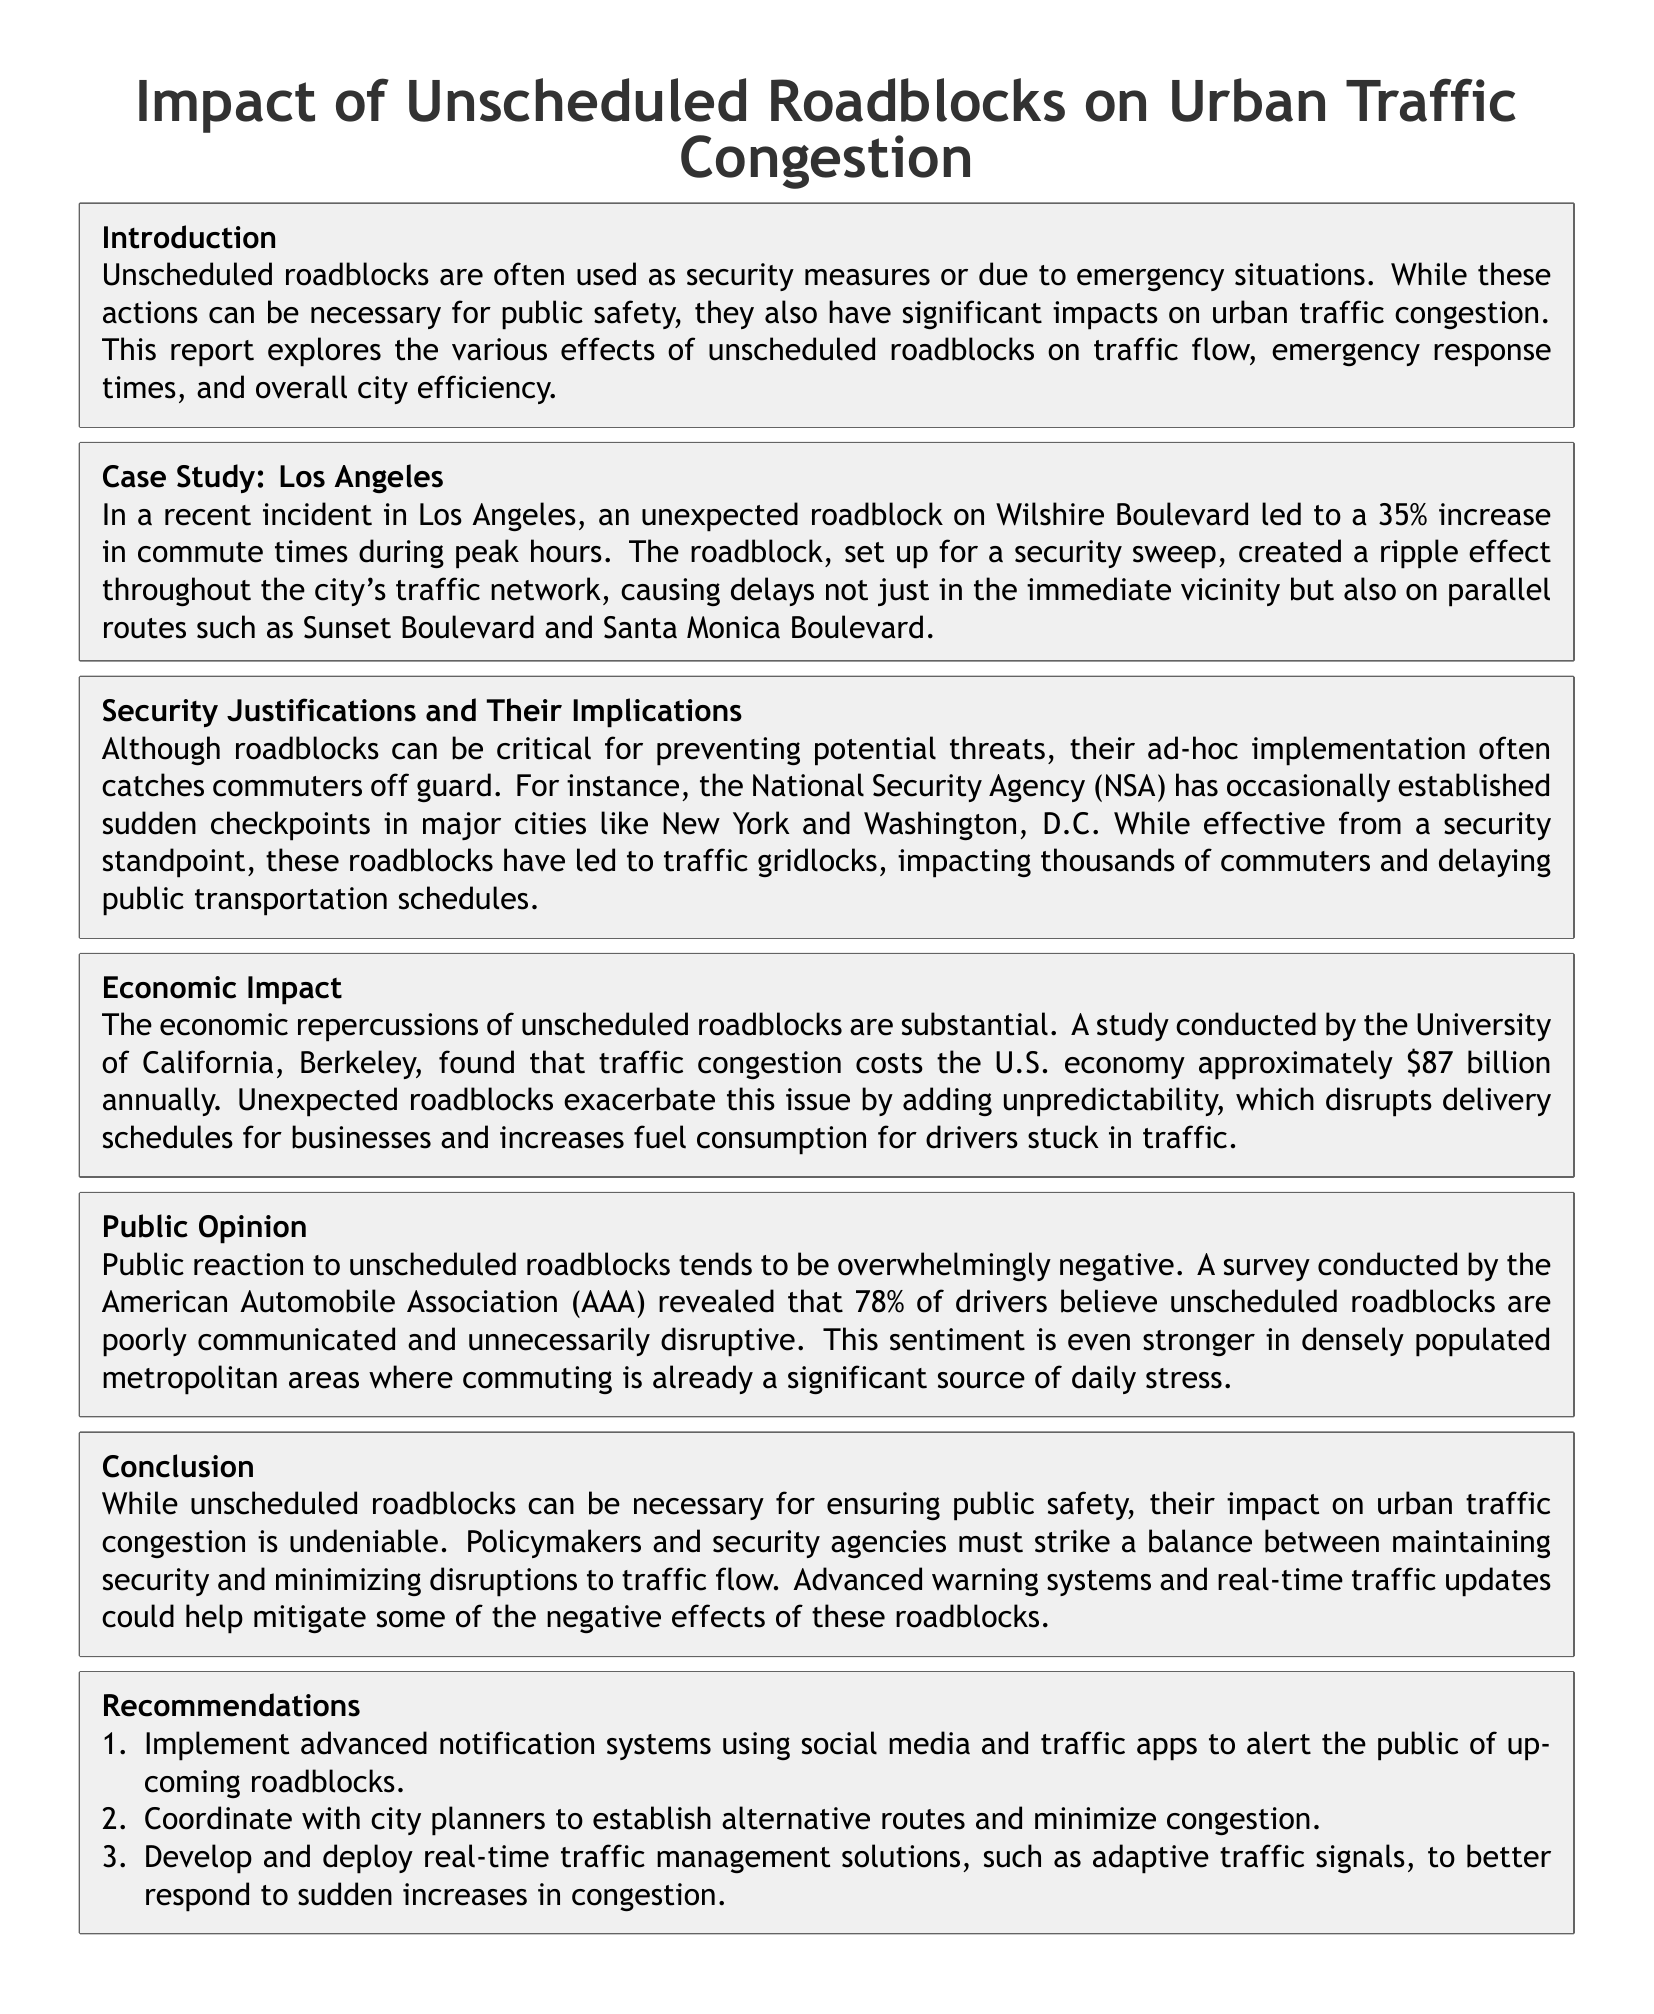What was the increase in commute times in Los Angeles due to the roadblock? The report states that the unexpected roadblock on Wilshire Boulevard led to a 35% increase in commute times.
Answer: 35% What is the annual cost of traffic congestion to the U.S. economy? According to the document, a study found that traffic congestion costs the U.S. economy approximately $87 billion annually.
Answer: $87 billion What percentage of drivers believe unscheduled roadblocks are poorly communicated? The survey conducted by the American Automobile Association revealed that 78% of drivers believe unscheduled roadblocks are poorly communicated.
Answer: 78% What is one proposed solution to minimize disruptions from roadblocks? One recommendation made in the report is to implement advanced notification systems using social media and traffic apps.
Answer: Advanced notification systems What incident was analyzed in the case study section of the report? The case study focuses on an unexpected roadblock in Los Angeles.
Answer: Los Angeles What major cities has the NSA established sudden checkpoints in? The document mentions New York and Washington, D.C. as cities where the NSA has established sudden checkpoints.
Answer: New York and Washington, D.C What is the public sentiment towards unscheduled roadblocks in metropolitan areas? The report indicates that the sentiment towards unscheduled roadblocks is overwhelmingly negative, especially in densely populated areas.
Answer: Overwhelmingly negative What are real-time traffic management solutions suggested in the report? The report suggests developing and deploying adaptive traffic signals as a real-time traffic management solution.
Answer: Adaptive traffic signals What is the primary focus of the report? The report focuses on the impact of unscheduled roadblocks on urban traffic congestion.
Answer: Impact of unscheduled roadblocks 